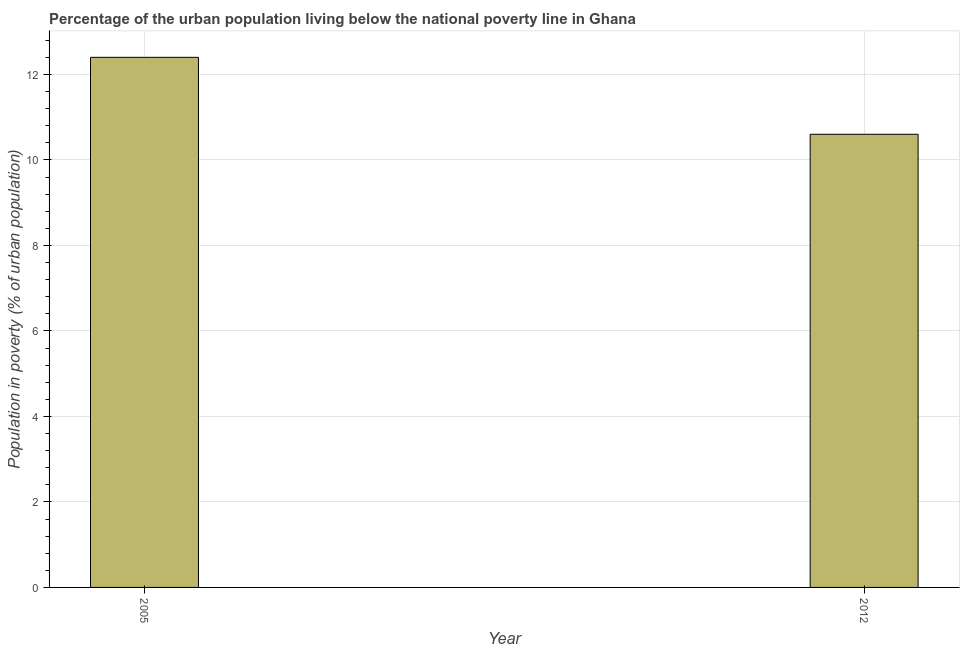Does the graph contain grids?
Your answer should be very brief. Yes. What is the title of the graph?
Your response must be concise. Percentage of the urban population living below the national poverty line in Ghana. What is the label or title of the Y-axis?
Offer a terse response. Population in poverty (% of urban population). Across all years, what is the maximum percentage of urban population living below poverty line?
Ensure brevity in your answer.  12.4. In which year was the percentage of urban population living below poverty line minimum?
Make the answer very short. 2012. What is the sum of the percentage of urban population living below poverty line?
Provide a short and direct response. 23. What is the average percentage of urban population living below poverty line per year?
Ensure brevity in your answer.  11.5. In how many years, is the percentage of urban population living below poverty line greater than 2.4 %?
Make the answer very short. 2. Do a majority of the years between 2012 and 2005 (inclusive) have percentage of urban population living below poverty line greater than 12.4 %?
Provide a short and direct response. No. What is the ratio of the percentage of urban population living below poverty line in 2005 to that in 2012?
Your answer should be very brief. 1.17. Is the percentage of urban population living below poverty line in 2005 less than that in 2012?
Offer a terse response. No. In how many years, is the percentage of urban population living below poverty line greater than the average percentage of urban population living below poverty line taken over all years?
Provide a short and direct response. 1. Are all the bars in the graph horizontal?
Provide a succinct answer. No. How many years are there in the graph?
Keep it short and to the point. 2. What is the difference between two consecutive major ticks on the Y-axis?
Make the answer very short. 2. What is the difference between the Population in poverty (% of urban population) in 2005 and 2012?
Your response must be concise. 1.8. What is the ratio of the Population in poverty (% of urban population) in 2005 to that in 2012?
Provide a short and direct response. 1.17. 